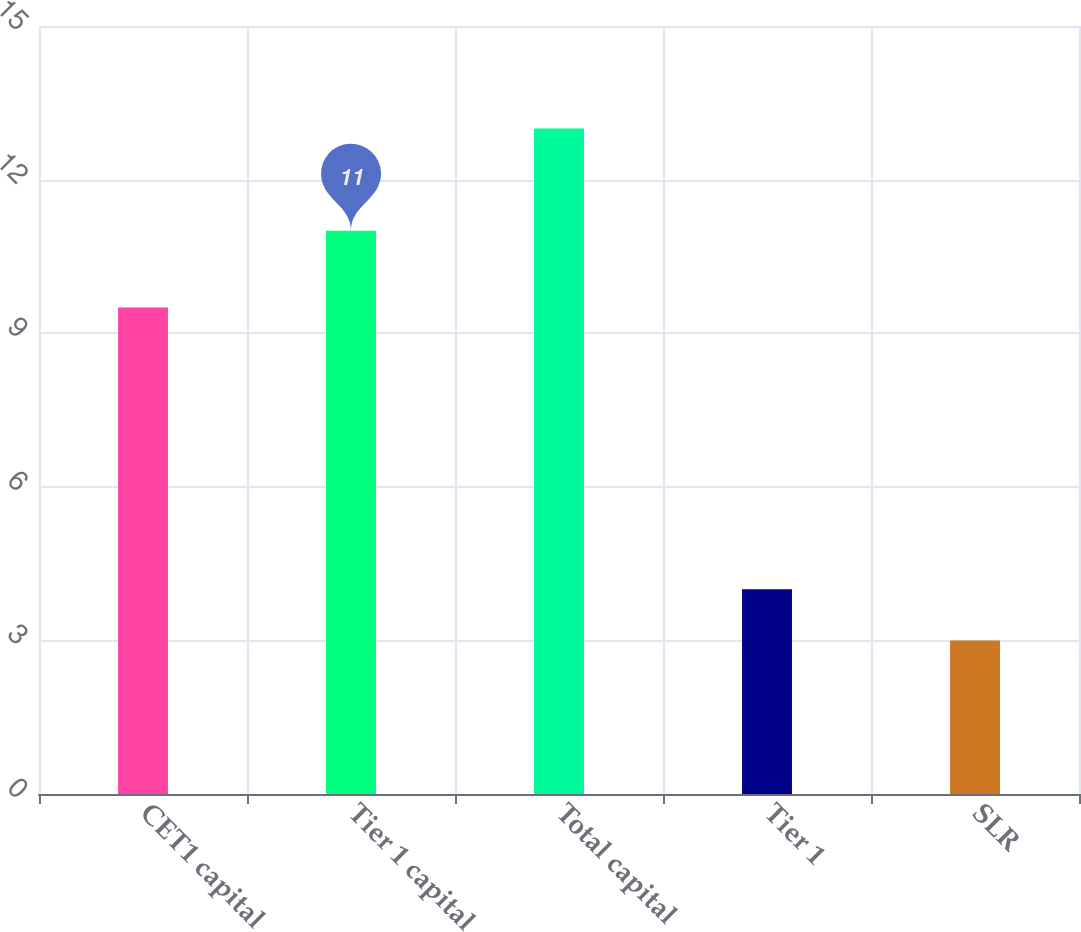Convert chart. <chart><loc_0><loc_0><loc_500><loc_500><bar_chart><fcel>CET1 capital<fcel>Tier 1 capital<fcel>Total capital<fcel>Tier 1<fcel>SLR<nl><fcel>9.5<fcel>11<fcel>13<fcel>4<fcel>3<nl></chart> 